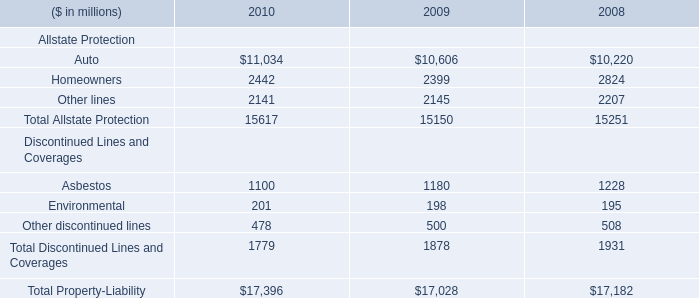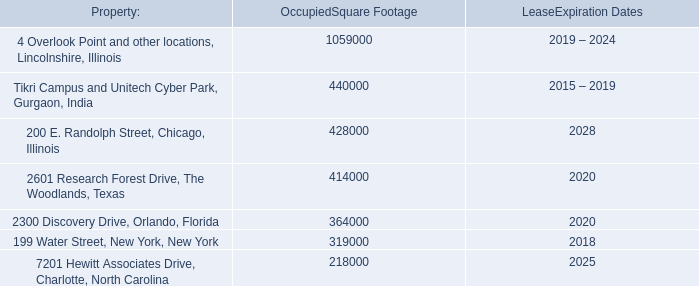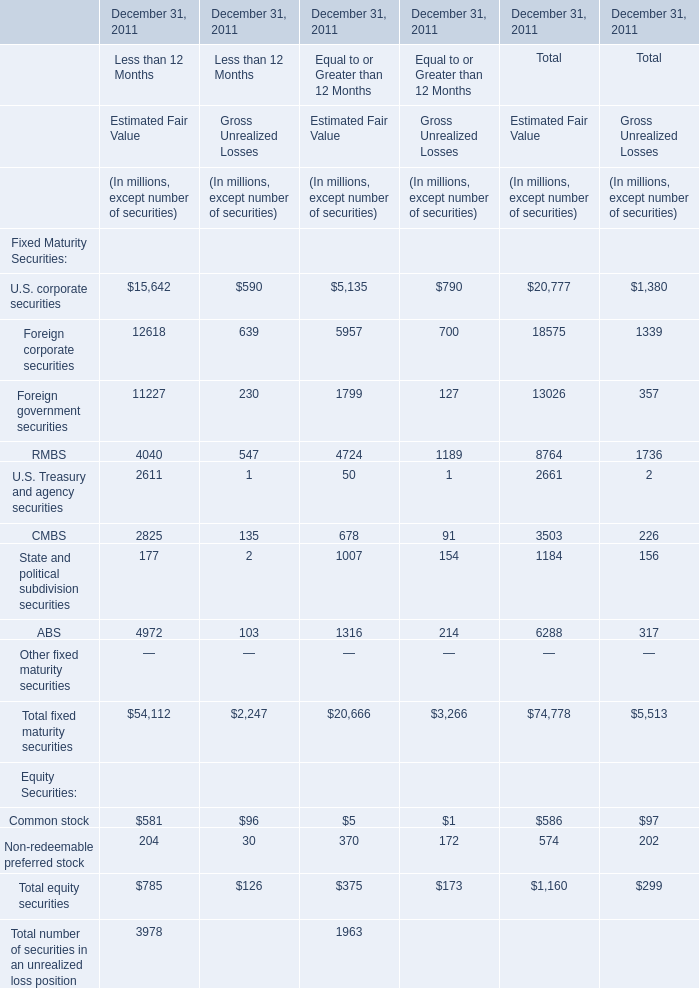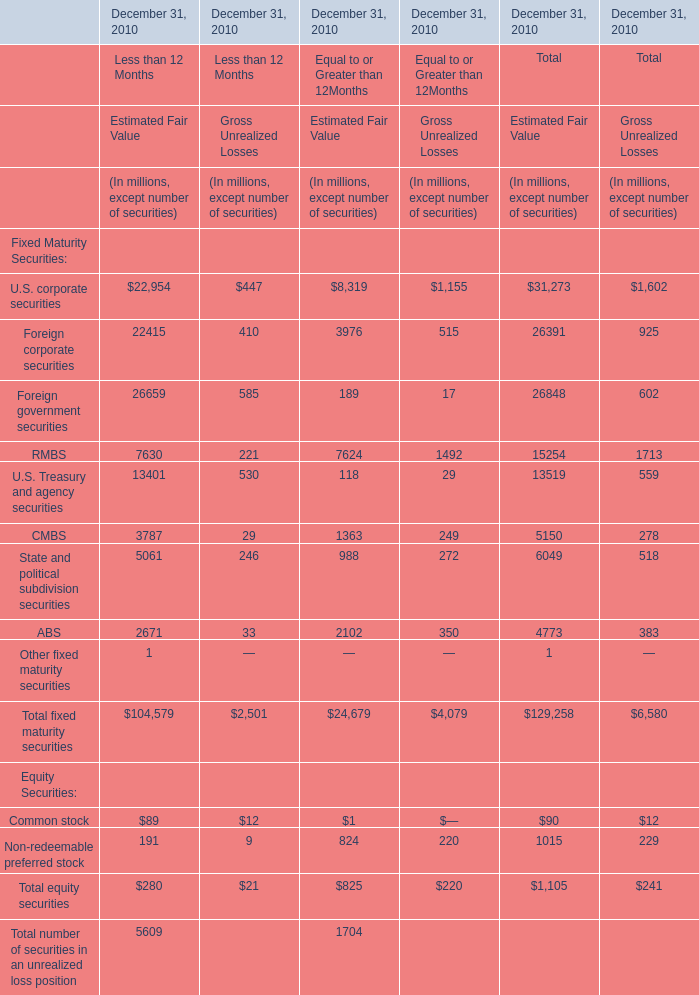how many years are left till the lease expiration date for the building of aon's corporate headquarters? 
Computations: (2034 - 2015)
Answer: 19.0. 